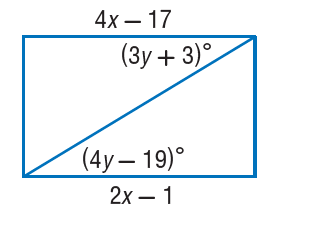Answer the mathemtical geometry problem and directly provide the correct option letter.
Question: Find x so that the quadrilateral is a parallelogram.
Choices: A: 5 B: 8 C: 9 D: 17 B 